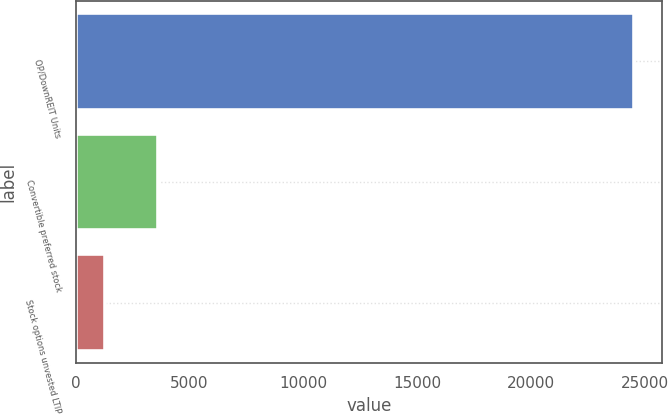Convert chart. <chart><loc_0><loc_0><loc_500><loc_500><bar_chart><fcel>OP/DownREIT Units<fcel>Convertible preferred stock<fcel>Stock options unvested LTIP<nl><fcel>24548<fcel>3628.4<fcel>1304<nl></chart> 